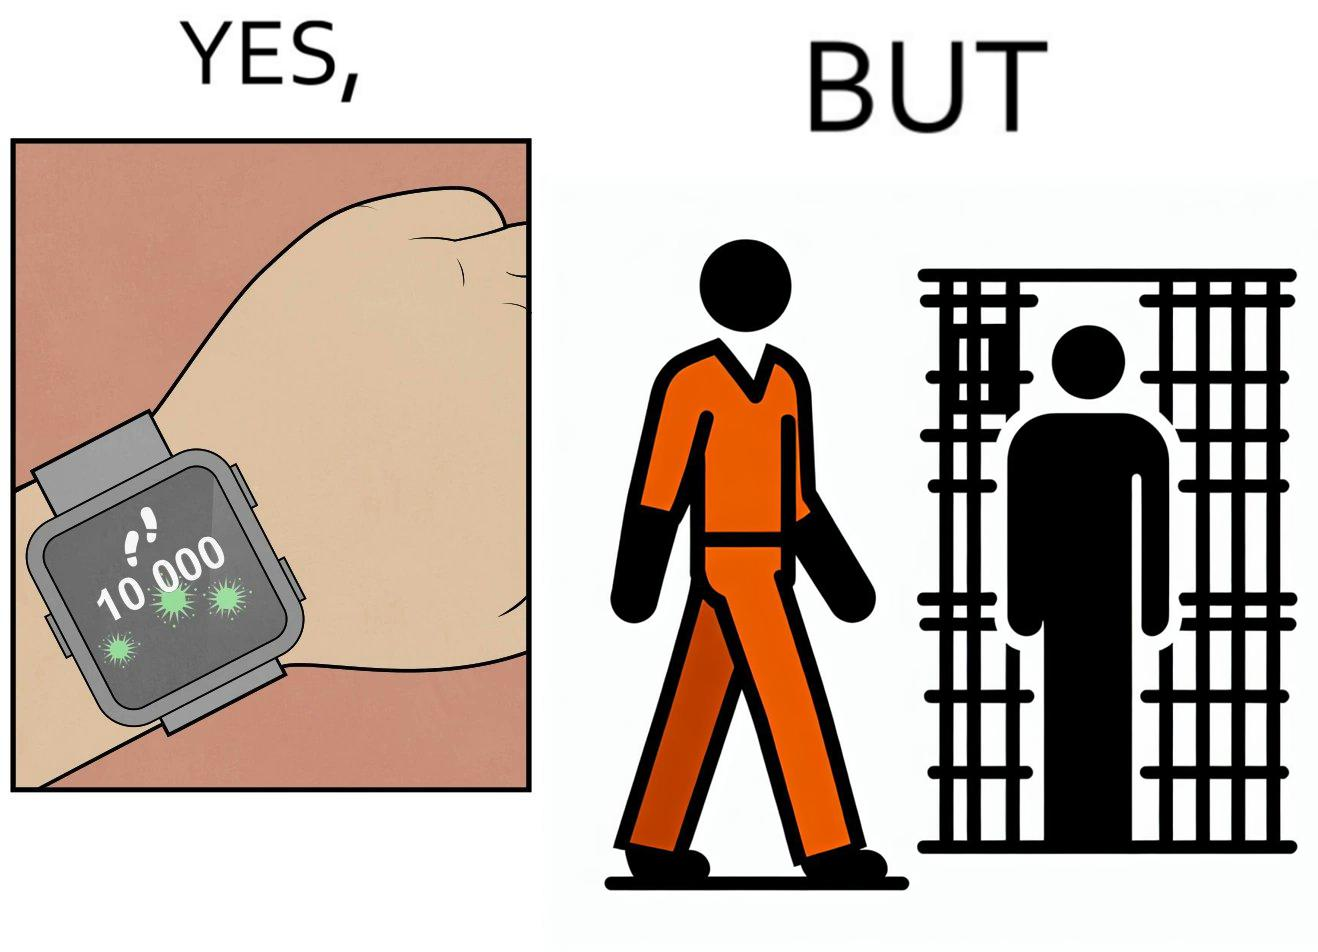Describe what you see in the left and right parts of this image. In the left part of the image: a smartwatch on a person's wrist showing 10,000 steps completed, indicating that a goal has been reached. In the right part of the image: a person walking in orange clothes, who is apparently a prisoner inside a jail. 